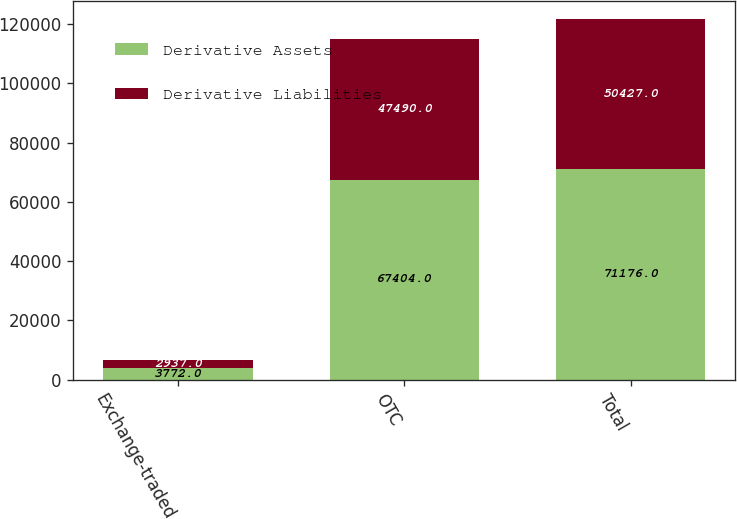<chart> <loc_0><loc_0><loc_500><loc_500><stacked_bar_chart><ecel><fcel>Exchange-traded<fcel>OTC<fcel>Total<nl><fcel>Derivative Assets<fcel>3772<fcel>67404<fcel>71176<nl><fcel>Derivative Liabilities<fcel>2937<fcel>47490<fcel>50427<nl></chart> 